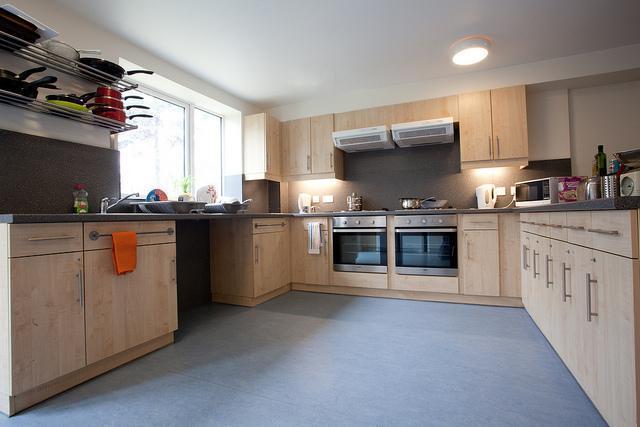How many ovens are in this kitchen?
Give a very brief answer. 2. How many dish towels are hanging on towel bars in this kitchen?
Give a very brief answer. 2. How many ovens are there?
Give a very brief answer. 2. How many people are visible to the left of the parked cars?
Give a very brief answer. 0. 